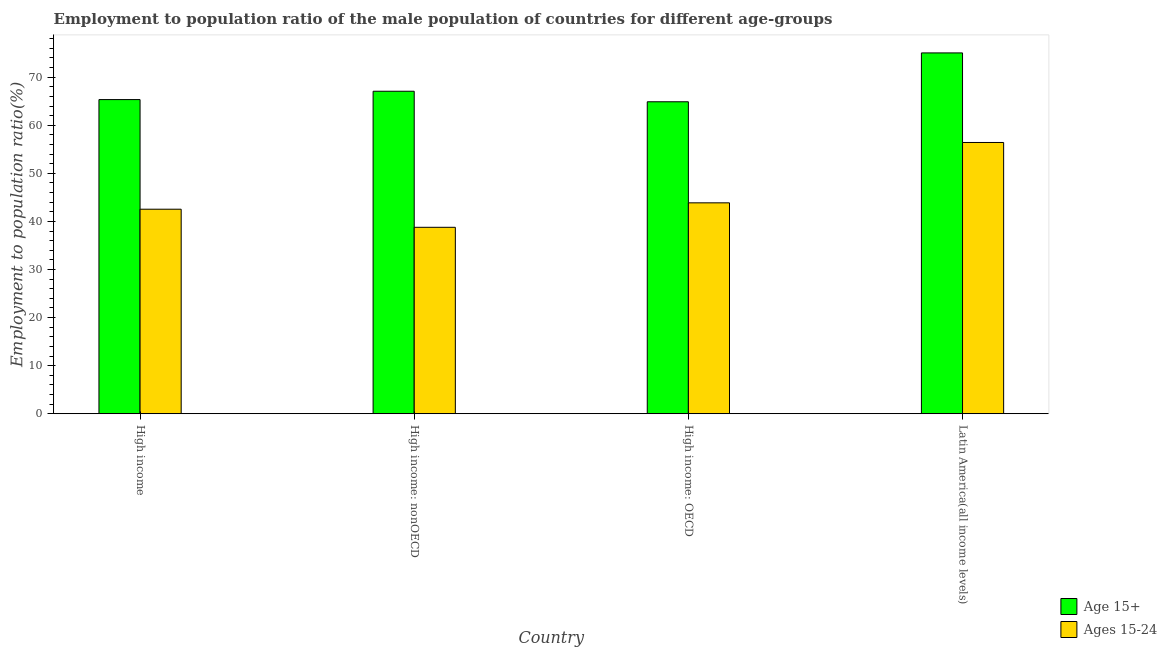How many different coloured bars are there?
Offer a terse response. 2. How many groups of bars are there?
Give a very brief answer. 4. Are the number of bars per tick equal to the number of legend labels?
Your answer should be compact. Yes. How many bars are there on the 4th tick from the left?
Make the answer very short. 2. What is the label of the 2nd group of bars from the left?
Provide a succinct answer. High income: nonOECD. What is the employment to population ratio(age 15+) in High income?
Provide a succinct answer. 65.34. Across all countries, what is the maximum employment to population ratio(age 15-24)?
Offer a terse response. 56.42. Across all countries, what is the minimum employment to population ratio(age 15-24)?
Make the answer very short. 38.78. In which country was the employment to population ratio(age 15-24) maximum?
Offer a terse response. Latin America(all income levels). In which country was the employment to population ratio(age 15-24) minimum?
Your response must be concise. High income: nonOECD. What is the total employment to population ratio(age 15-24) in the graph?
Your answer should be compact. 181.6. What is the difference between the employment to population ratio(age 15-24) in High income and that in Latin America(all income levels)?
Give a very brief answer. -13.88. What is the difference between the employment to population ratio(age 15+) in High income: nonOECD and the employment to population ratio(age 15-24) in High income?
Your response must be concise. 24.54. What is the average employment to population ratio(age 15-24) per country?
Provide a succinct answer. 45.4. What is the difference between the employment to population ratio(age 15+) and employment to population ratio(age 15-24) in High income: OECD?
Your response must be concise. 21.02. In how many countries, is the employment to population ratio(age 15+) greater than 2 %?
Your answer should be very brief. 4. What is the ratio of the employment to population ratio(age 15+) in High income: nonOECD to that in Latin America(all income levels)?
Provide a short and direct response. 0.89. Is the employment to population ratio(age 15-24) in High income less than that in High income: OECD?
Offer a terse response. Yes. Is the difference between the employment to population ratio(age 15+) in High income: OECD and High income: nonOECD greater than the difference between the employment to population ratio(age 15-24) in High income: OECD and High income: nonOECD?
Offer a terse response. No. What is the difference between the highest and the second highest employment to population ratio(age 15+)?
Provide a short and direct response. 7.97. What is the difference between the highest and the lowest employment to population ratio(age 15-24)?
Your answer should be very brief. 17.64. In how many countries, is the employment to population ratio(age 15-24) greater than the average employment to population ratio(age 15-24) taken over all countries?
Make the answer very short. 1. What does the 1st bar from the left in Latin America(all income levels) represents?
Offer a terse response. Age 15+. What does the 2nd bar from the right in High income represents?
Offer a terse response. Age 15+. How many bars are there?
Offer a terse response. 8. How many countries are there in the graph?
Your answer should be compact. 4. Does the graph contain any zero values?
Offer a terse response. No. How are the legend labels stacked?
Your response must be concise. Vertical. What is the title of the graph?
Make the answer very short. Employment to population ratio of the male population of countries for different age-groups. What is the label or title of the Y-axis?
Ensure brevity in your answer.  Employment to population ratio(%). What is the Employment to population ratio(%) in Age 15+ in High income?
Make the answer very short. 65.34. What is the Employment to population ratio(%) in Ages 15-24 in High income?
Offer a terse response. 42.54. What is the Employment to population ratio(%) of Age 15+ in High income: nonOECD?
Your answer should be very brief. 67.08. What is the Employment to population ratio(%) in Ages 15-24 in High income: nonOECD?
Give a very brief answer. 38.78. What is the Employment to population ratio(%) of Age 15+ in High income: OECD?
Offer a very short reply. 64.89. What is the Employment to population ratio(%) in Ages 15-24 in High income: OECD?
Ensure brevity in your answer.  43.87. What is the Employment to population ratio(%) in Age 15+ in Latin America(all income levels)?
Make the answer very short. 75.05. What is the Employment to population ratio(%) in Ages 15-24 in Latin America(all income levels)?
Offer a very short reply. 56.42. Across all countries, what is the maximum Employment to population ratio(%) in Age 15+?
Offer a terse response. 75.05. Across all countries, what is the maximum Employment to population ratio(%) in Ages 15-24?
Your answer should be very brief. 56.42. Across all countries, what is the minimum Employment to population ratio(%) in Age 15+?
Give a very brief answer. 64.89. Across all countries, what is the minimum Employment to population ratio(%) in Ages 15-24?
Give a very brief answer. 38.78. What is the total Employment to population ratio(%) in Age 15+ in the graph?
Make the answer very short. 272.35. What is the total Employment to population ratio(%) of Ages 15-24 in the graph?
Provide a succinct answer. 181.6. What is the difference between the Employment to population ratio(%) in Age 15+ in High income and that in High income: nonOECD?
Offer a very short reply. -1.74. What is the difference between the Employment to population ratio(%) of Ages 15-24 in High income and that in High income: nonOECD?
Offer a very short reply. 3.76. What is the difference between the Employment to population ratio(%) of Age 15+ in High income and that in High income: OECD?
Your answer should be very brief. 0.45. What is the difference between the Employment to population ratio(%) in Ages 15-24 in High income and that in High income: OECD?
Offer a very short reply. -1.33. What is the difference between the Employment to population ratio(%) of Age 15+ in High income and that in Latin America(all income levels)?
Your answer should be compact. -9.71. What is the difference between the Employment to population ratio(%) in Ages 15-24 in High income and that in Latin America(all income levels)?
Your answer should be very brief. -13.88. What is the difference between the Employment to population ratio(%) in Age 15+ in High income: nonOECD and that in High income: OECD?
Make the answer very short. 2.19. What is the difference between the Employment to population ratio(%) of Ages 15-24 in High income: nonOECD and that in High income: OECD?
Make the answer very short. -5.09. What is the difference between the Employment to population ratio(%) of Age 15+ in High income: nonOECD and that in Latin America(all income levels)?
Your answer should be very brief. -7.97. What is the difference between the Employment to population ratio(%) of Ages 15-24 in High income: nonOECD and that in Latin America(all income levels)?
Offer a terse response. -17.64. What is the difference between the Employment to population ratio(%) of Age 15+ in High income: OECD and that in Latin America(all income levels)?
Your response must be concise. -10.16. What is the difference between the Employment to population ratio(%) in Ages 15-24 in High income: OECD and that in Latin America(all income levels)?
Your answer should be compact. -12.55. What is the difference between the Employment to population ratio(%) in Age 15+ in High income and the Employment to population ratio(%) in Ages 15-24 in High income: nonOECD?
Your answer should be compact. 26.56. What is the difference between the Employment to population ratio(%) of Age 15+ in High income and the Employment to population ratio(%) of Ages 15-24 in High income: OECD?
Provide a short and direct response. 21.47. What is the difference between the Employment to population ratio(%) in Age 15+ in High income and the Employment to population ratio(%) in Ages 15-24 in Latin America(all income levels)?
Provide a short and direct response. 8.92. What is the difference between the Employment to population ratio(%) in Age 15+ in High income: nonOECD and the Employment to population ratio(%) in Ages 15-24 in High income: OECD?
Your response must be concise. 23.21. What is the difference between the Employment to population ratio(%) of Age 15+ in High income: nonOECD and the Employment to population ratio(%) of Ages 15-24 in Latin America(all income levels)?
Make the answer very short. 10.66. What is the difference between the Employment to population ratio(%) in Age 15+ in High income: OECD and the Employment to population ratio(%) in Ages 15-24 in Latin America(all income levels)?
Your answer should be very brief. 8.47. What is the average Employment to population ratio(%) in Age 15+ per country?
Make the answer very short. 68.09. What is the average Employment to population ratio(%) of Ages 15-24 per country?
Keep it short and to the point. 45.4. What is the difference between the Employment to population ratio(%) in Age 15+ and Employment to population ratio(%) in Ages 15-24 in High income?
Provide a short and direct response. 22.8. What is the difference between the Employment to population ratio(%) of Age 15+ and Employment to population ratio(%) of Ages 15-24 in High income: nonOECD?
Offer a terse response. 28.3. What is the difference between the Employment to population ratio(%) in Age 15+ and Employment to population ratio(%) in Ages 15-24 in High income: OECD?
Your answer should be very brief. 21.02. What is the difference between the Employment to population ratio(%) of Age 15+ and Employment to population ratio(%) of Ages 15-24 in Latin America(all income levels)?
Offer a very short reply. 18.63. What is the ratio of the Employment to population ratio(%) of Age 15+ in High income to that in High income: nonOECD?
Make the answer very short. 0.97. What is the ratio of the Employment to population ratio(%) of Ages 15-24 in High income to that in High income: nonOECD?
Offer a terse response. 1.1. What is the ratio of the Employment to population ratio(%) in Age 15+ in High income to that in High income: OECD?
Offer a terse response. 1.01. What is the ratio of the Employment to population ratio(%) in Ages 15-24 in High income to that in High income: OECD?
Ensure brevity in your answer.  0.97. What is the ratio of the Employment to population ratio(%) of Age 15+ in High income to that in Latin America(all income levels)?
Keep it short and to the point. 0.87. What is the ratio of the Employment to population ratio(%) of Ages 15-24 in High income to that in Latin America(all income levels)?
Offer a very short reply. 0.75. What is the ratio of the Employment to population ratio(%) of Age 15+ in High income: nonOECD to that in High income: OECD?
Your answer should be compact. 1.03. What is the ratio of the Employment to population ratio(%) of Ages 15-24 in High income: nonOECD to that in High income: OECD?
Your response must be concise. 0.88. What is the ratio of the Employment to population ratio(%) of Age 15+ in High income: nonOECD to that in Latin America(all income levels)?
Provide a succinct answer. 0.89. What is the ratio of the Employment to population ratio(%) in Ages 15-24 in High income: nonOECD to that in Latin America(all income levels)?
Offer a very short reply. 0.69. What is the ratio of the Employment to population ratio(%) in Age 15+ in High income: OECD to that in Latin America(all income levels)?
Ensure brevity in your answer.  0.86. What is the ratio of the Employment to population ratio(%) in Ages 15-24 in High income: OECD to that in Latin America(all income levels)?
Offer a terse response. 0.78. What is the difference between the highest and the second highest Employment to population ratio(%) in Age 15+?
Give a very brief answer. 7.97. What is the difference between the highest and the second highest Employment to population ratio(%) of Ages 15-24?
Offer a terse response. 12.55. What is the difference between the highest and the lowest Employment to population ratio(%) of Age 15+?
Keep it short and to the point. 10.16. What is the difference between the highest and the lowest Employment to population ratio(%) in Ages 15-24?
Your response must be concise. 17.64. 